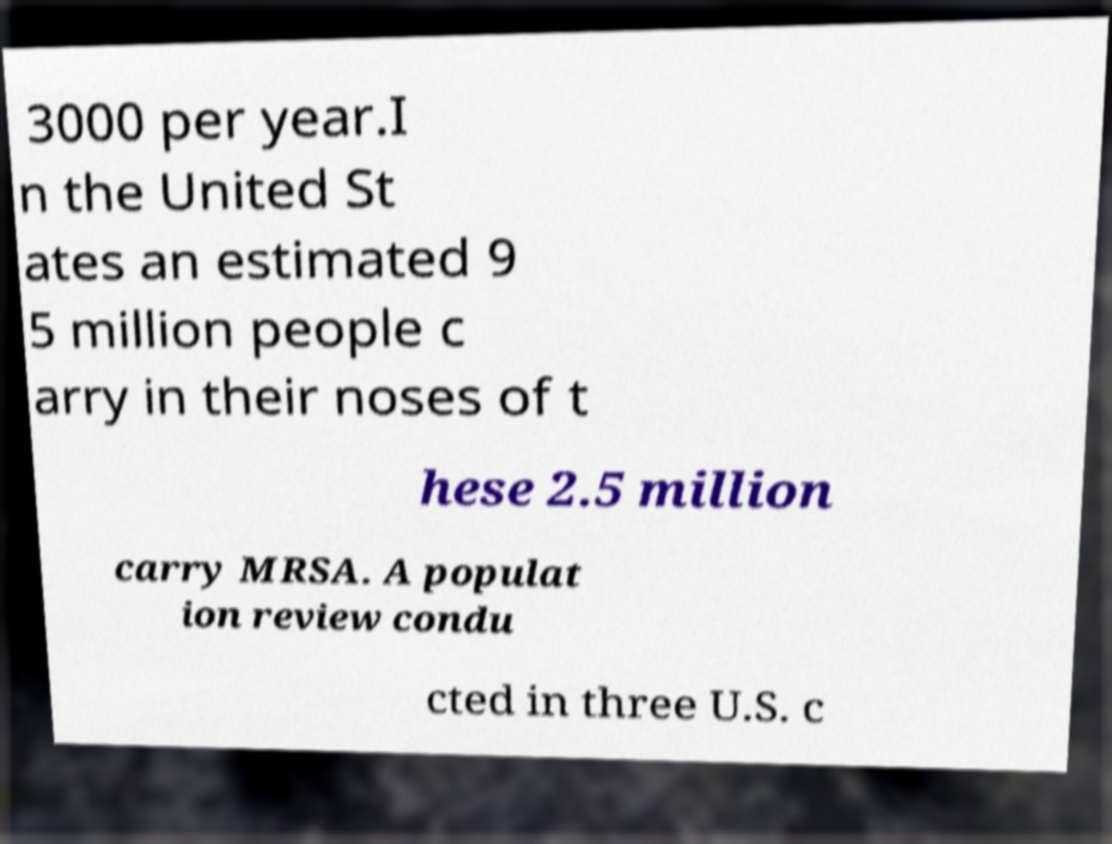For documentation purposes, I need the text within this image transcribed. Could you provide that? 3000 per year.I n the United St ates an estimated 9 5 million people c arry in their noses of t hese 2.5 million carry MRSA. A populat ion review condu cted in three U.S. c 